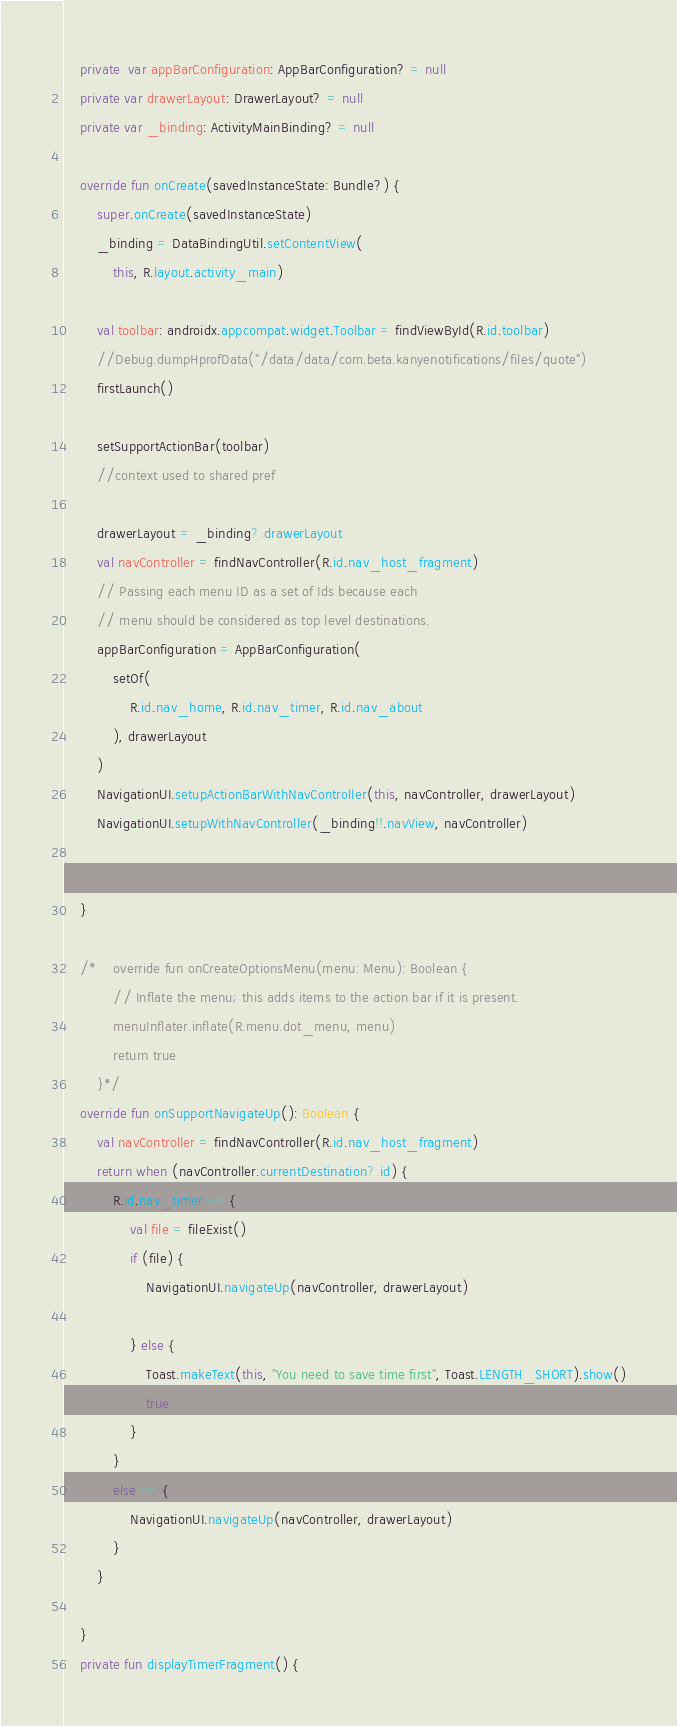<code> <loc_0><loc_0><loc_500><loc_500><_Kotlin_>    private  var appBarConfiguration: AppBarConfiguration? = null
    private var drawerLayout: DrawerLayout? = null
    private var _binding: ActivityMainBinding? = null

    override fun onCreate(savedInstanceState: Bundle?) {
        super.onCreate(savedInstanceState)
        _binding = DataBindingUtil.setContentView(
            this, R.layout.activity_main)

        val toolbar: androidx.appcompat.widget.Toolbar = findViewById(R.id.toolbar)
        //Debug.dumpHprofData("/data/data/com.beta.kanyenotifications/files/quote")
        firstLaunch()

        setSupportActionBar(toolbar)
        //context used to shared pref

        drawerLayout = _binding?.drawerLayout
        val navController = findNavController(R.id.nav_host_fragment)
        // Passing each menu ID as a set of Ids because each
        // menu should be considered as top level destinations.
        appBarConfiguration = AppBarConfiguration(
            setOf(
                R.id.nav_home, R.id.nav_timer, R.id.nav_about
            ), drawerLayout
        )
        NavigationUI.setupActionBarWithNavController(this, navController, drawerLayout)
        NavigationUI.setupWithNavController(_binding!!.navView, navController)


    }

    /*    override fun onCreateOptionsMenu(menu: Menu): Boolean {
            // Inflate the menu; this adds items to the action bar if it is present.
            menuInflater.inflate(R.menu.dot_menu, menu)
            return true
        }*/
    override fun onSupportNavigateUp(): Boolean {
        val navController = findNavController(R.id.nav_host_fragment)
        return when (navController.currentDestination?.id) {
            R.id.nav_timer -> {
                val file = fileExist()
                if (file) {
                    NavigationUI.navigateUp(navController, drawerLayout)

                } else {
                    Toast.makeText(this, "You need to save time first", Toast.LENGTH_SHORT).show()
                    true
                }
            }
            else -> {
                NavigationUI.navigateUp(navController, drawerLayout)
            }
        }

    }
    private fun displayTimerFragment() {</code> 